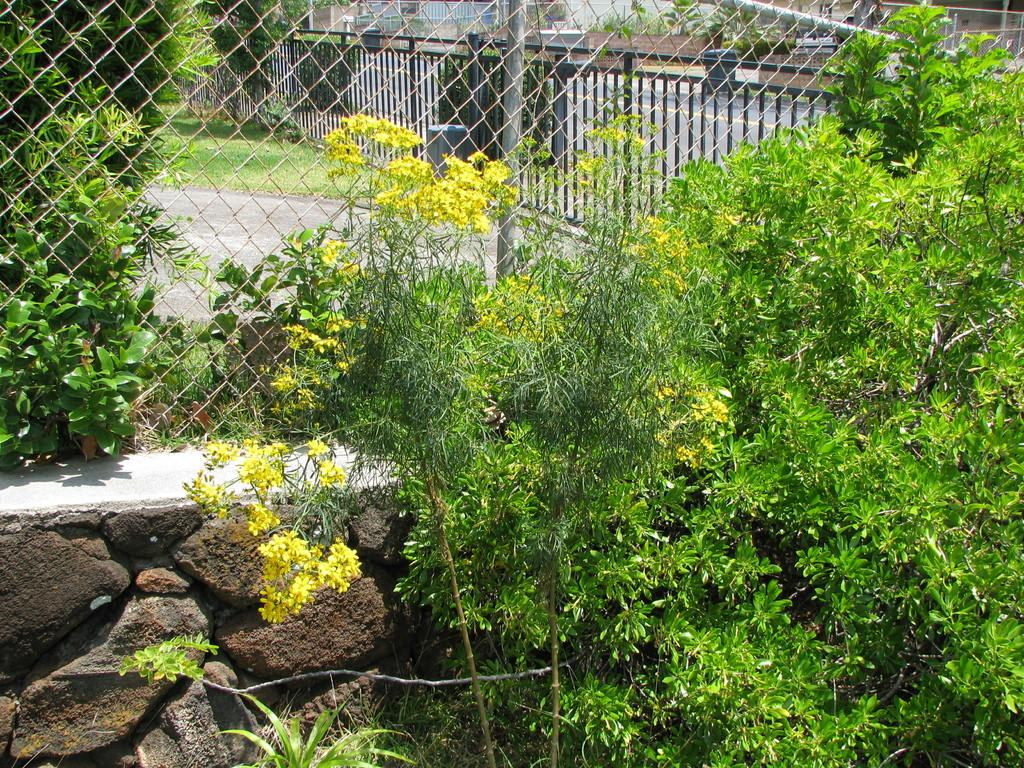What types of living organisms can be seen in the image? Plants and flowers are visible in the image. What natural elements can be seen in the image? Rocks and grass are visible in the image. What structures are present in the image? There is a fence in the center of the image, and there are railings, a walkway, poles, and buildings in the background of the image. What type of wax is being applied to the toe in the image? There is no toe or wax present in the image; it features plants, flowers, rocks, a fence, railings, a walkway, poles, and buildings. 